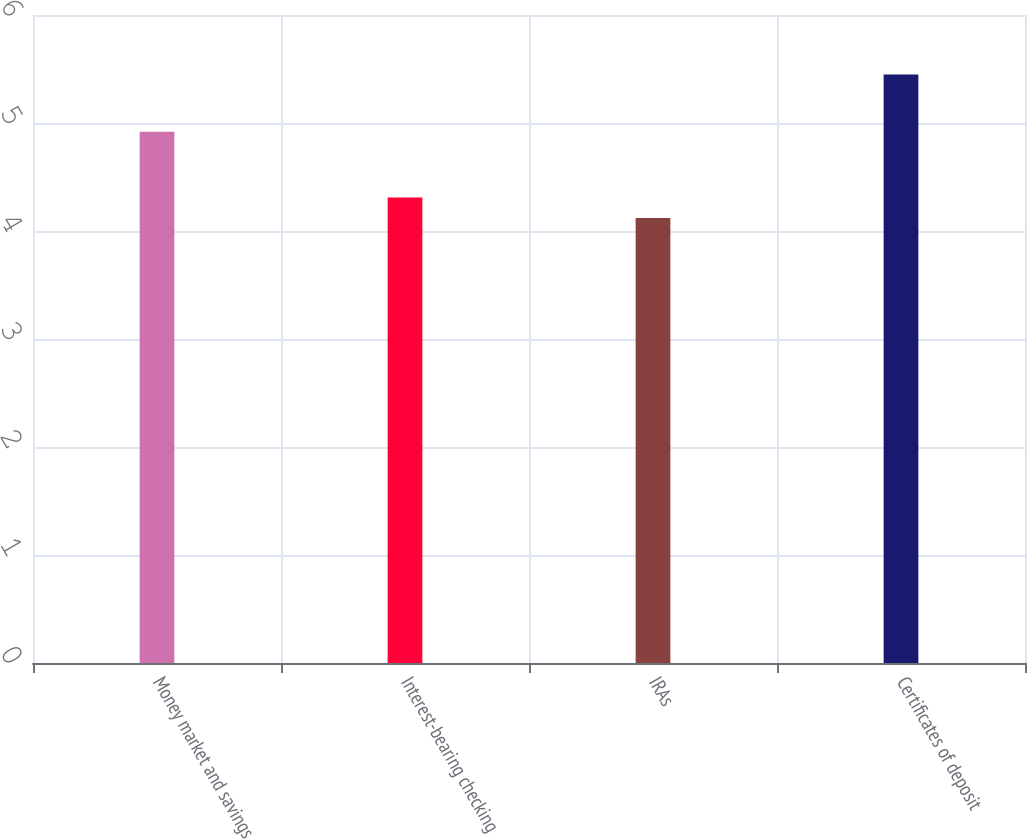<chart> <loc_0><loc_0><loc_500><loc_500><bar_chart><fcel>Money market and savings<fcel>Interest-bearing checking<fcel>IRAs<fcel>Certificates of deposit<nl><fcel>4.92<fcel>4.31<fcel>4.12<fcel>5.45<nl></chart> 